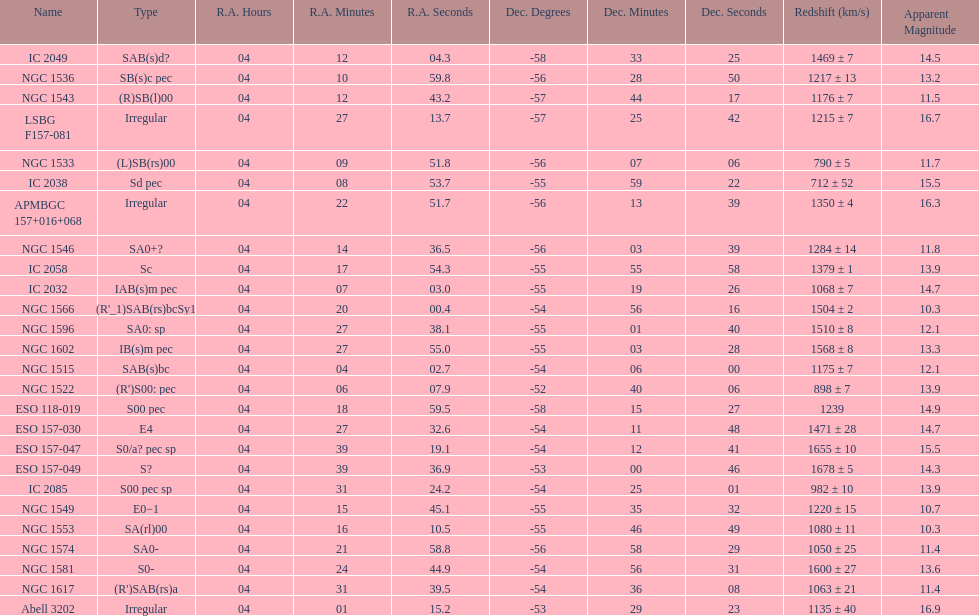What number of "irregular" types are there? 3. Could you parse the entire table as a dict? {'header': ['Name', 'Type', 'R.A. Hours', 'R.A. Minutes', 'R.A. Seconds', 'Dec. Degrees', 'Dec. Minutes', 'Dec. Seconds', 'Redshift (km/s)', 'Apparent Magnitude'], 'rows': [['IC 2049', 'SAB(s)d?', '04', '12', '04.3', '-58', '33', '25', '1469 ± 7', '14.5'], ['NGC 1536', 'SB(s)c pec', '04', '10', '59.8', '-56', '28', '50', '1217 ± 13', '13.2'], ['NGC 1543', '(R)SB(l)00', '04', '12', '43.2', '-57', '44', '17', '1176 ± 7', '11.5'], ['LSBG F157-081', 'Irregular', '04', '27', '13.7', '-57', '25', '42', '1215 ± 7', '16.7'], ['NGC 1533', '(L)SB(rs)00', '04', '09', '51.8', '-56', '07', '06', '790 ± 5', '11.7'], ['IC 2038', 'Sd pec', '04', '08', '53.7', '-55', '59', '22', '712 ± 52', '15.5'], ['APMBGC 157+016+068', 'Irregular', '04', '22', '51.7', '-56', '13', '39', '1350 ± 4', '16.3'], ['NGC 1546', 'SA0+?', '04', '14', '36.5', '-56', '03', '39', '1284 ± 14', '11.8'], ['IC 2058', 'Sc', '04', '17', '54.3', '-55', '55', '58', '1379 ± 1', '13.9'], ['IC 2032', 'IAB(s)m pec', '04', '07', '03.0', '-55', '19', '26', '1068 ± 7', '14.7'], ['NGC 1566', "(R'_1)SAB(rs)bcSy1", '04', '20', '00.4', '-54', '56', '16', '1504 ± 2', '10.3'], ['NGC 1596', 'SA0: sp', '04', '27', '38.1', '-55', '01', '40', '1510 ± 8', '12.1'], ['NGC 1602', 'IB(s)m pec', '04', '27', '55.0', '-55', '03', '28', '1568 ± 8', '13.3'], ['NGC 1515', 'SAB(s)bc', '04', '04', '02.7', '-54', '06', '00', '1175 ± 7', '12.1'], ['NGC 1522', "(R')S00: pec", '04', '06', '07.9', '-52', '40', '06', '898 ± 7', '13.9'], ['ESO 118-019', 'S00 pec', '04', '18', '59.5', '-58', '15', '27', '1239', '14.9'], ['ESO 157-030', 'E4', '04', '27', '32.6', '-54', '11', '48', '1471 ± 28', '14.7'], ['ESO 157-047', 'S0/a? pec sp', '04', '39', '19.1', '-54', '12', '41', '1655 ± 10', '15.5'], ['ESO 157-049', 'S?', '04', '39', '36.9', '-53', '00', '46', '1678 ± 5', '14.3'], ['IC 2085', 'S00 pec sp', '04', '31', '24.2', '-54', '25', '01', '982 ± 10', '13.9'], ['NGC 1549', 'E0−1', '04', '15', '45.1', '-55', '35', '32', '1220 ± 15', '10.7'], ['NGC 1553', 'SA(rl)00', '04', '16', '10.5', '-55', '46', '49', '1080 ± 11', '10.3'], ['NGC 1574', 'SA0-', '04', '21', '58.8', '-56', '58', '29', '1050 ± 25', '11.4'], ['NGC 1581', 'S0-', '04', '24', '44.9', '-54', '56', '31', '1600 ± 27', '13.6'], ['NGC 1617', "(R')SAB(rs)a", '04', '31', '39.5', '-54', '36', '08', '1063 ± 21', '11.4'], ['Abell 3202', 'Irregular', '04', '01', '15.2', '-53', '29', '23', '1135 ± 40', '16.9']]} 